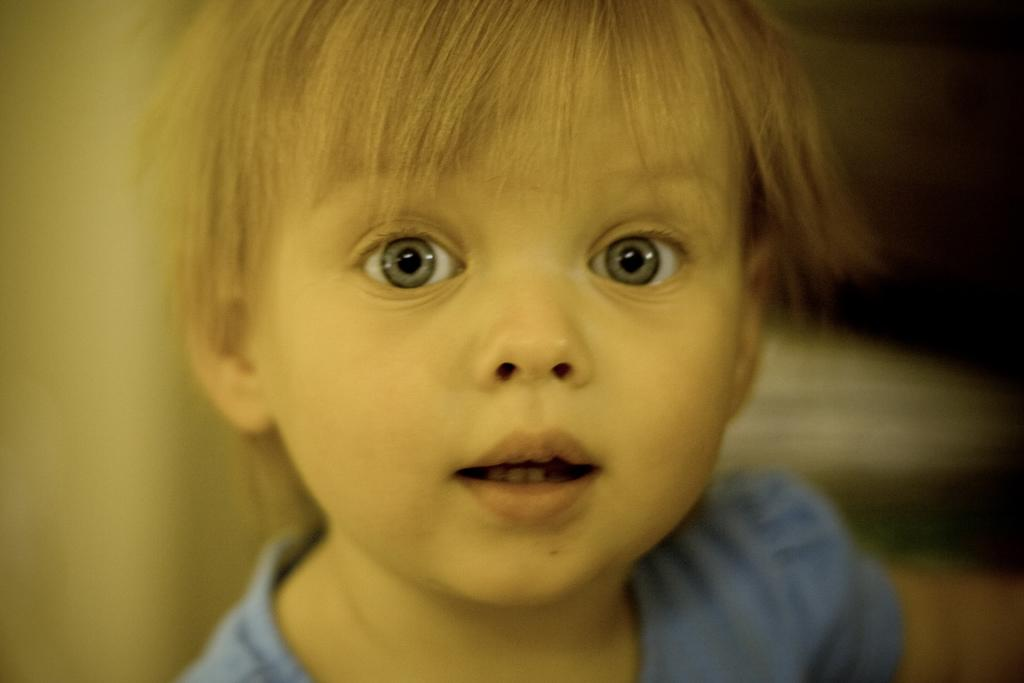What is the main subject of the image? There is a child in the image. Can you describe the background of the image? The background of the image is blurry. What type of knowledge can be seen on the lamp in the image? There is no lamp present in the image, so it is not possible to determine what type of knowledge might be on it. 